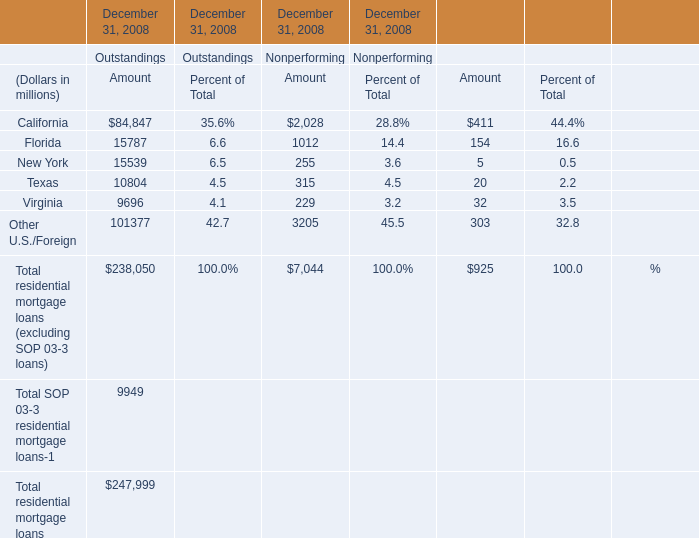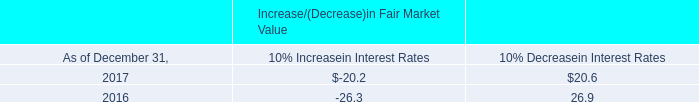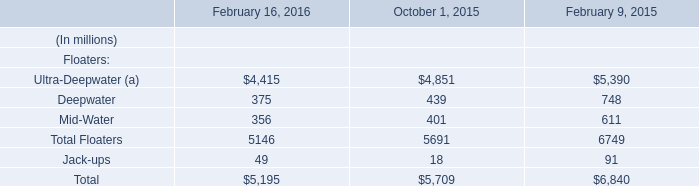What's the greatest value of Outstandings in 2008? (in million) 
Answer: 238050. 